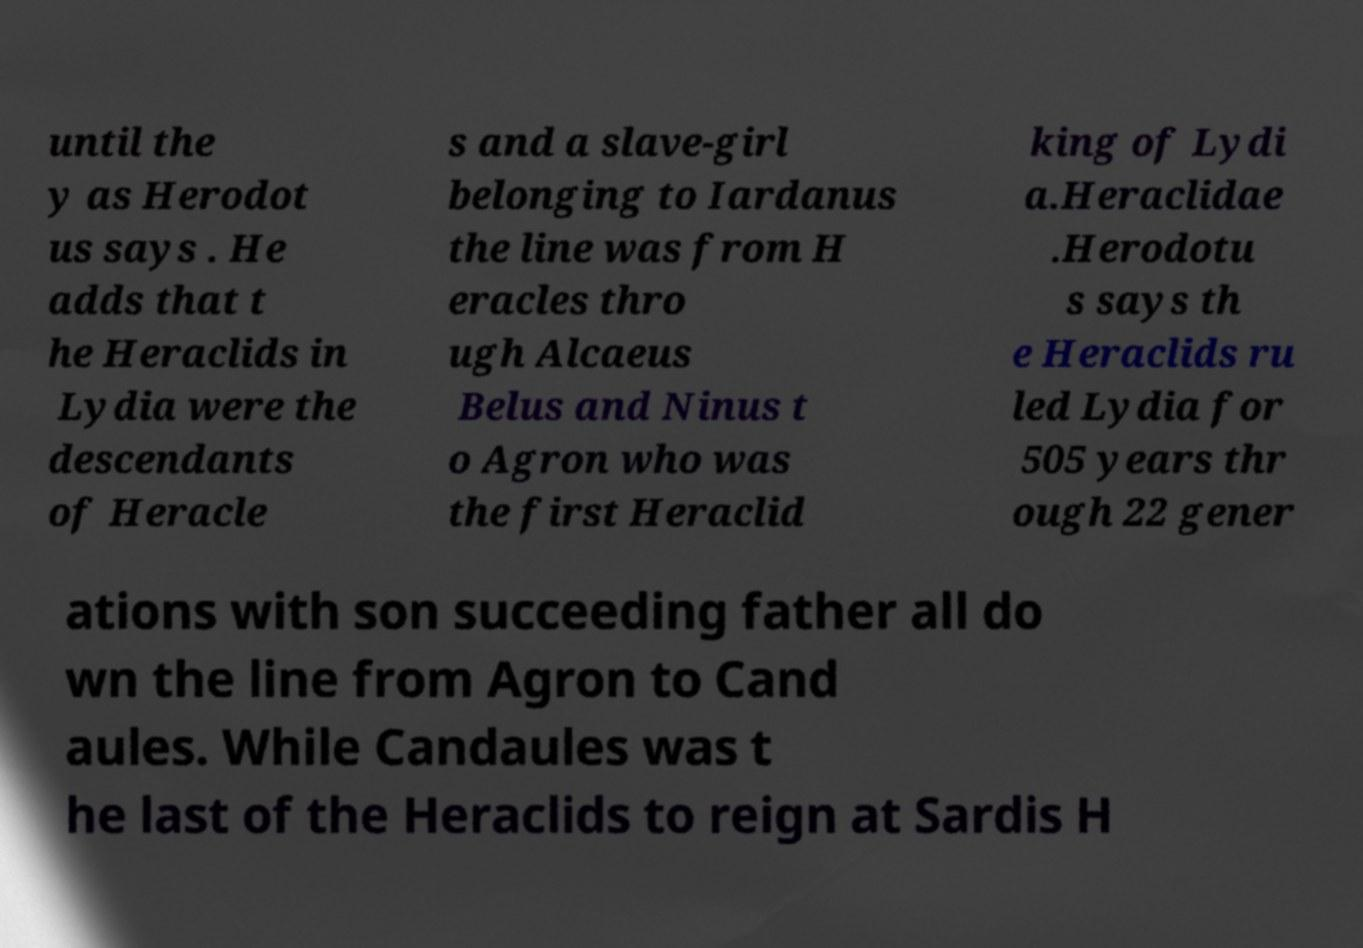Please identify and transcribe the text found in this image. until the y as Herodot us says . He adds that t he Heraclids in Lydia were the descendants of Heracle s and a slave-girl belonging to Iardanus the line was from H eracles thro ugh Alcaeus Belus and Ninus t o Agron who was the first Heraclid king of Lydi a.Heraclidae .Herodotu s says th e Heraclids ru led Lydia for 505 years thr ough 22 gener ations with son succeeding father all do wn the line from Agron to Cand aules. While Candaules was t he last of the Heraclids to reign at Sardis H 